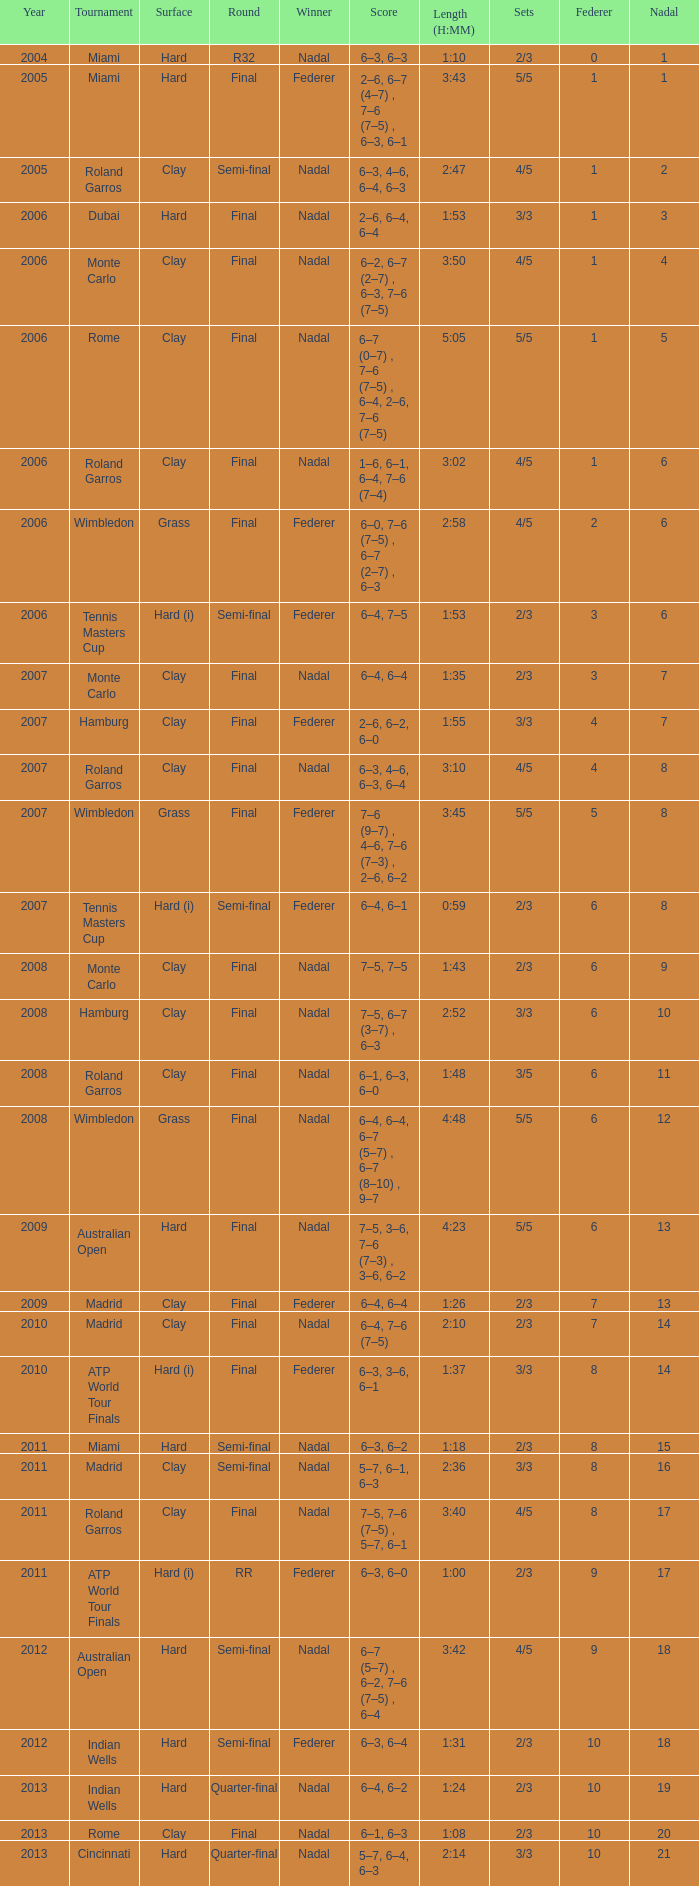What was the nadal in Miami in the final round? 1.0. 